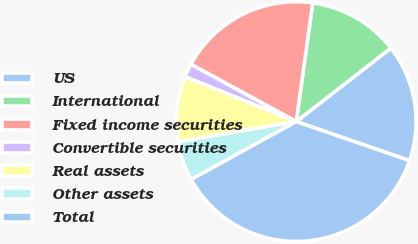Convert chart. <chart><loc_0><loc_0><loc_500><loc_500><pie_chart><fcel>US<fcel>International<fcel>Fixed income securities<fcel>Convertible securities<fcel>Real assets<fcel>Other assets<fcel>Total<nl><fcel>15.78%<fcel>12.29%<fcel>19.27%<fcel>1.83%<fcel>8.81%<fcel>5.32%<fcel>36.7%<nl></chart> 